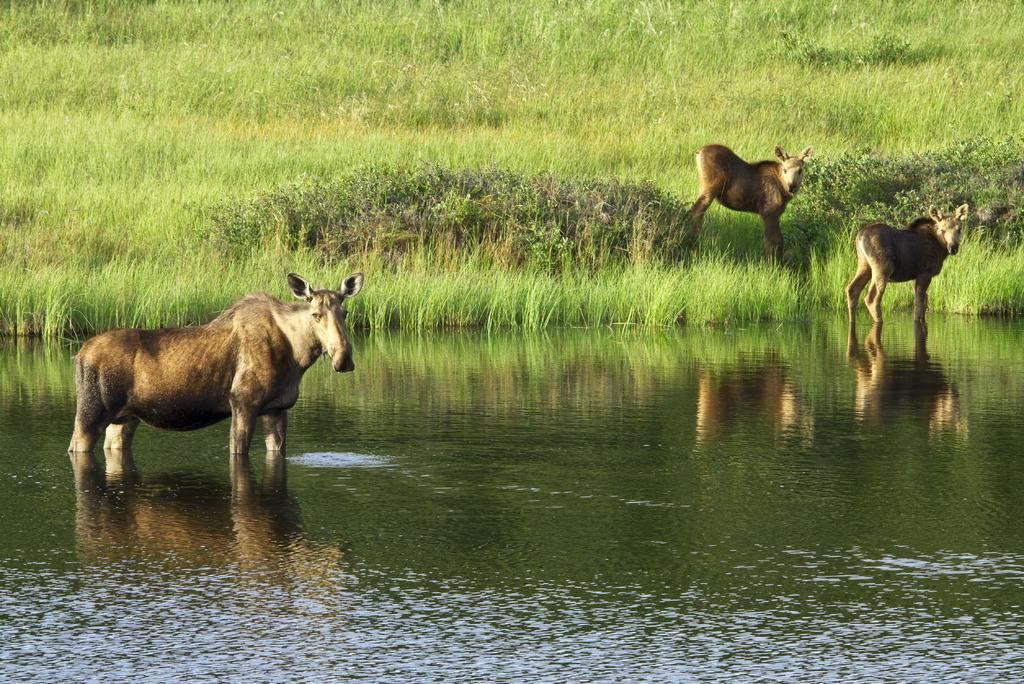What types of living organisms can be seen in the image? There are animals in the image. What natural element is visible in the image? Water and grass are visible in the image. What is the reaction of the cat to the water in the image? There is no cat present in the image, so it is not possible to determine its reaction to the water. 